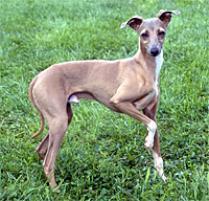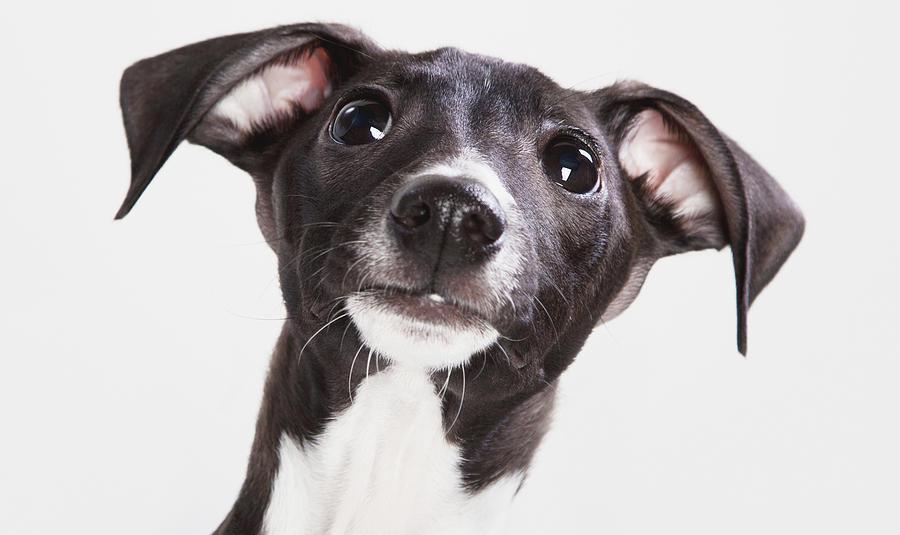The first image is the image on the left, the second image is the image on the right. Analyze the images presented: Is the assertion "One image shows a light brown dog standing." valid? Answer yes or no. Yes. 